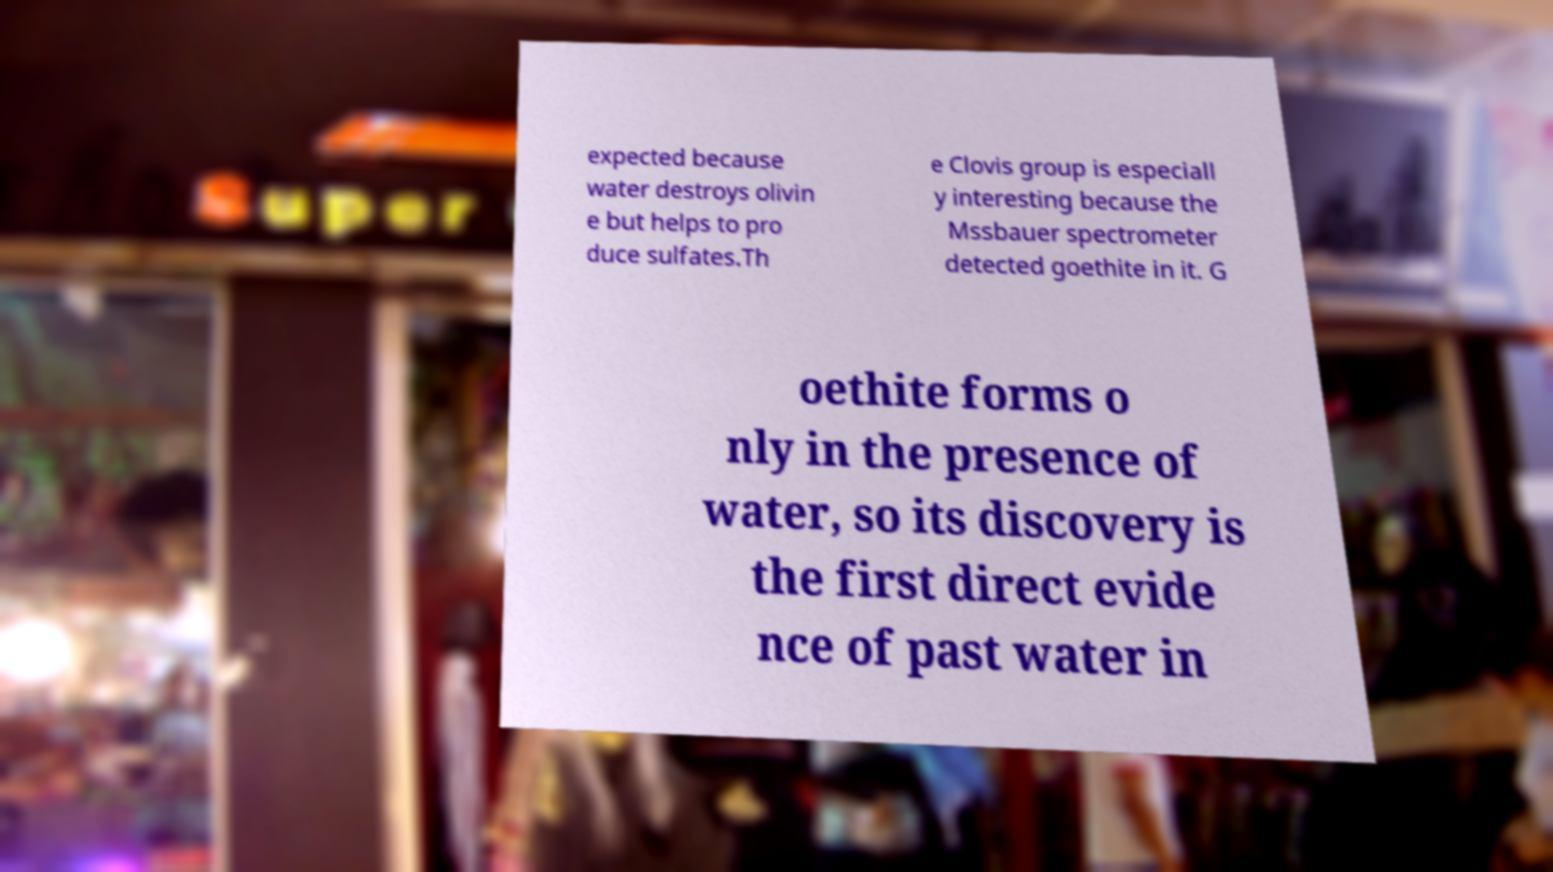Can you read and provide the text displayed in the image?This photo seems to have some interesting text. Can you extract and type it out for me? expected because water destroys olivin e but helps to pro duce sulfates.Th e Clovis group is especiall y interesting because the Mssbauer spectrometer detected goethite in it. G oethite forms o nly in the presence of water, so its discovery is the first direct evide nce of past water in 